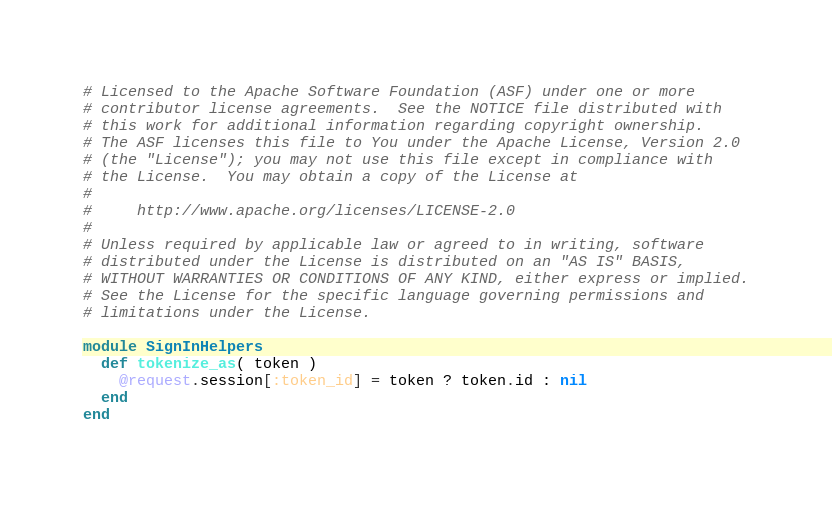<code> <loc_0><loc_0><loc_500><loc_500><_Ruby_># Licensed to the Apache Software Foundation (ASF) under one or more
# contributor license agreements.  See the NOTICE file distributed with
# this work for additional information regarding copyright ownership.
# The ASF licenses this file to You under the Apache License, Version 2.0
# (the "License"); you may not use this file except in compliance with
# the License.  You may obtain a copy of the License at
#
#     http://www.apache.org/licenses/LICENSE-2.0
#
# Unless required by applicable law or agreed to in writing, software
# distributed under the License is distributed on an "AS IS" BASIS,
# WITHOUT WARRANTIES OR CONDITIONS OF ANY KIND, either express or implied.
# See the License for the specific language governing permissions and
# limitations under the License.

module SignInHelpers
  def tokenize_as( token )
    @request.session[:token_id] = token ? token.id : nil
  end
end
</code> 